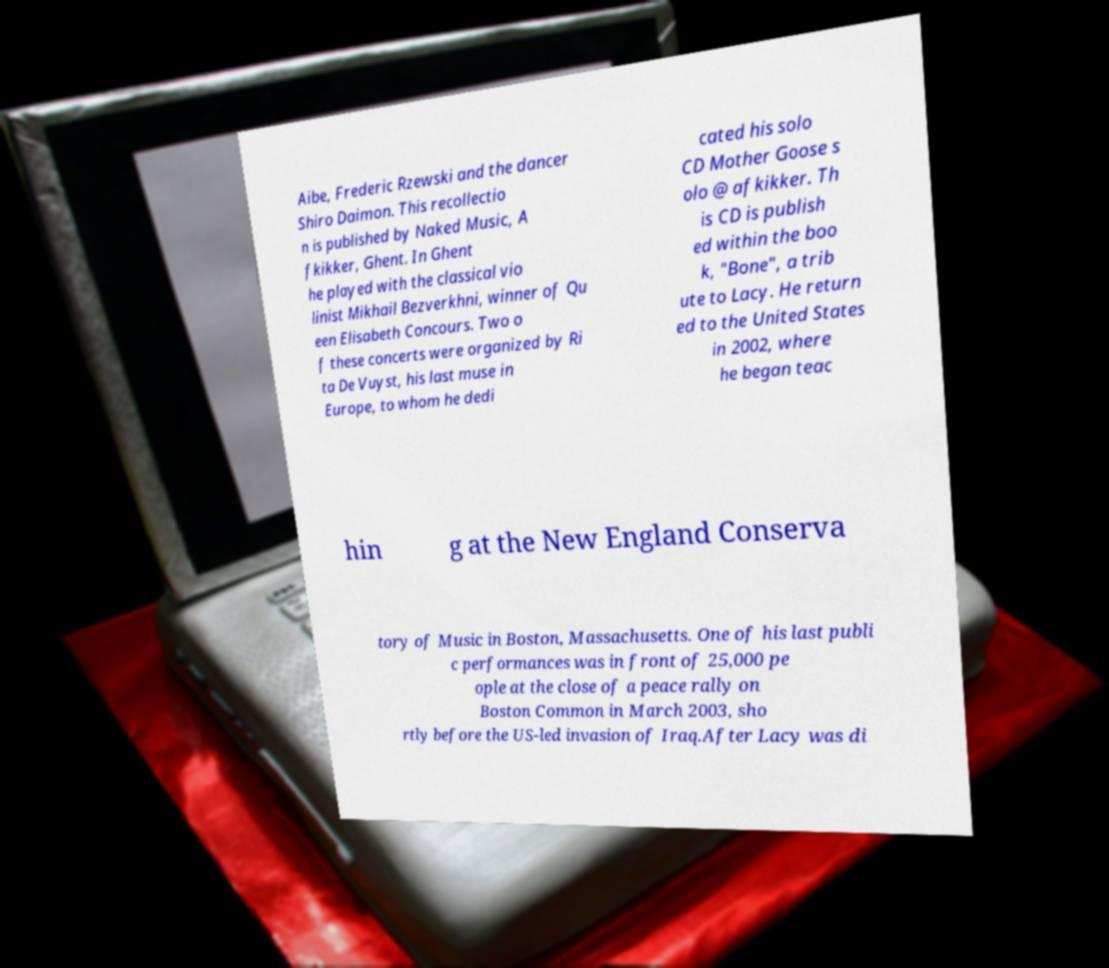Please read and relay the text visible in this image. What does it say? Aibe, Frederic Rzewski and the dancer Shiro Daimon. This recollectio n is published by Naked Music, A fkikker, Ghent. In Ghent he played with the classical vio linist Mikhail Bezverkhni, winner of Qu een Elisabeth Concours. Two o f these concerts were organized by Ri ta De Vuyst, his last muse in Europe, to whom he dedi cated his solo CD Mother Goose s olo @ afkikker. Th is CD is publish ed within the boo k, "Bone", a trib ute to Lacy. He return ed to the United States in 2002, where he began teac hin g at the New England Conserva tory of Music in Boston, Massachusetts. One of his last publi c performances was in front of 25,000 pe ople at the close of a peace rally on Boston Common in March 2003, sho rtly before the US-led invasion of Iraq.After Lacy was di 